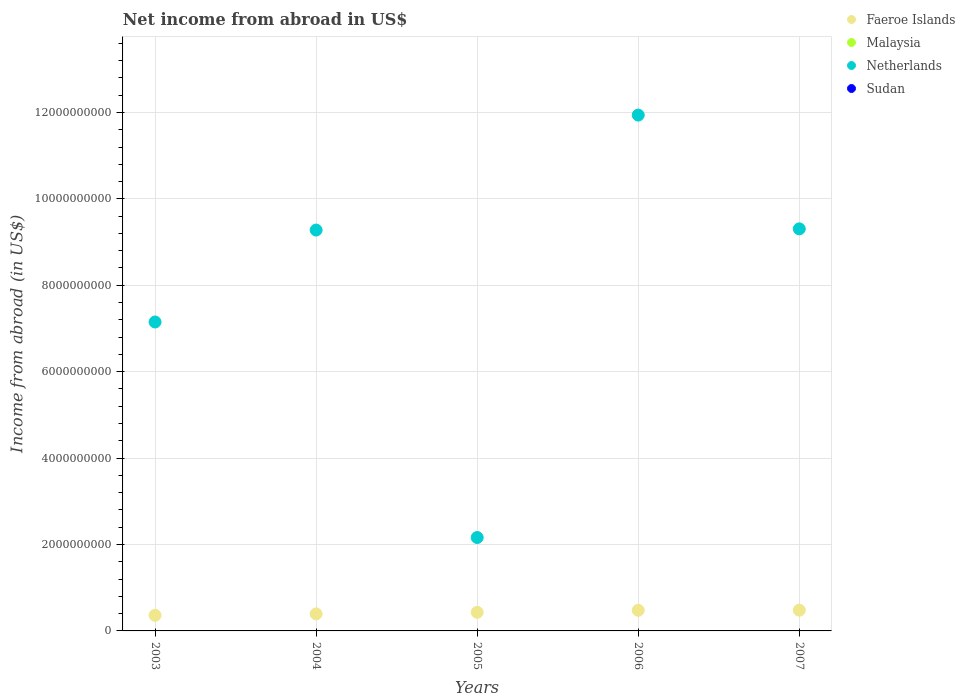How many different coloured dotlines are there?
Make the answer very short. 2. Is the number of dotlines equal to the number of legend labels?
Your answer should be compact. No. What is the net income from abroad in Netherlands in 2003?
Provide a short and direct response. 7.15e+09. Across all years, what is the maximum net income from abroad in Faeroe Islands?
Your answer should be very brief. 4.80e+08. What is the total net income from abroad in Faeroe Islands in the graph?
Offer a very short reply. 2.14e+09. What is the difference between the net income from abroad in Netherlands in 2006 and that in 2007?
Offer a very short reply. 2.63e+09. What is the difference between the net income from abroad in Sudan in 2004 and the net income from abroad in Faeroe Islands in 2007?
Ensure brevity in your answer.  -4.80e+08. What is the average net income from abroad in Faeroe Islands per year?
Keep it short and to the point. 4.29e+08. In the year 2006, what is the difference between the net income from abroad in Faeroe Islands and net income from abroad in Netherlands?
Make the answer very short. -1.15e+1. What is the ratio of the net income from abroad in Faeroe Islands in 2003 to that in 2004?
Keep it short and to the point. 0.92. Is the difference between the net income from abroad in Faeroe Islands in 2003 and 2007 greater than the difference between the net income from abroad in Netherlands in 2003 and 2007?
Give a very brief answer. Yes. What is the difference between the highest and the second highest net income from abroad in Netherlands?
Your response must be concise. 2.63e+09. What is the difference between the highest and the lowest net income from abroad in Netherlands?
Offer a very short reply. 9.78e+09. In how many years, is the net income from abroad in Netherlands greater than the average net income from abroad in Netherlands taken over all years?
Make the answer very short. 3. Does the net income from abroad in Sudan monotonically increase over the years?
Ensure brevity in your answer.  No. Is the net income from abroad in Netherlands strictly greater than the net income from abroad in Malaysia over the years?
Provide a succinct answer. Yes. Is the net income from abroad in Netherlands strictly less than the net income from abroad in Malaysia over the years?
Keep it short and to the point. No. What is the difference between two consecutive major ticks on the Y-axis?
Make the answer very short. 2.00e+09. Are the values on the major ticks of Y-axis written in scientific E-notation?
Offer a very short reply. No. Does the graph contain grids?
Keep it short and to the point. Yes. What is the title of the graph?
Your response must be concise. Net income from abroad in US$. What is the label or title of the X-axis?
Your response must be concise. Years. What is the label or title of the Y-axis?
Give a very brief answer. Income from abroad (in US$). What is the Income from abroad (in US$) of Faeroe Islands in 2003?
Keep it short and to the point. 3.62e+08. What is the Income from abroad (in US$) of Netherlands in 2003?
Keep it short and to the point. 7.15e+09. What is the Income from abroad (in US$) of Faeroe Islands in 2004?
Your response must be concise. 3.94e+08. What is the Income from abroad (in US$) of Netherlands in 2004?
Your answer should be very brief. 9.28e+09. What is the Income from abroad (in US$) in Faeroe Islands in 2005?
Give a very brief answer. 4.31e+08. What is the Income from abroad (in US$) of Malaysia in 2005?
Offer a very short reply. 0. What is the Income from abroad (in US$) of Netherlands in 2005?
Ensure brevity in your answer.  2.16e+09. What is the Income from abroad (in US$) of Faeroe Islands in 2006?
Your answer should be very brief. 4.77e+08. What is the Income from abroad (in US$) of Netherlands in 2006?
Your answer should be very brief. 1.19e+1. What is the Income from abroad (in US$) in Faeroe Islands in 2007?
Your response must be concise. 4.80e+08. What is the Income from abroad (in US$) in Malaysia in 2007?
Your answer should be very brief. 0. What is the Income from abroad (in US$) of Netherlands in 2007?
Make the answer very short. 9.31e+09. Across all years, what is the maximum Income from abroad (in US$) of Faeroe Islands?
Your response must be concise. 4.80e+08. Across all years, what is the maximum Income from abroad (in US$) of Netherlands?
Offer a very short reply. 1.19e+1. Across all years, what is the minimum Income from abroad (in US$) in Faeroe Islands?
Your answer should be very brief. 3.62e+08. Across all years, what is the minimum Income from abroad (in US$) in Netherlands?
Provide a short and direct response. 2.16e+09. What is the total Income from abroad (in US$) of Faeroe Islands in the graph?
Provide a short and direct response. 2.14e+09. What is the total Income from abroad (in US$) of Malaysia in the graph?
Provide a succinct answer. 0. What is the total Income from abroad (in US$) in Netherlands in the graph?
Ensure brevity in your answer.  3.98e+1. What is the difference between the Income from abroad (in US$) of Faeroe Islands in 2003 and that in 2004?
Make the answer very short. -3.25e+07. What is the difference between the Income from abroad (in US$) of Netherlands in 2003 and that in 2004?
Ensure brevity in your answer.  -2.13e+09. What is the difference between the Income from abroad (in US$) in Faeroe Islands in 2003 and that in 2005?
Your answer should be very brief. -6.92e+07. What is the difference between the Income from abroad (in US$) of Netherlands in 2003 and that in 2005?
Make the answer very short. 4.99e+09. What is the difference between the Income from abroad (in US$) of Faeroe Islands in 2003 and that in 2006?
Offer a terse response. -1.15e+08. What is the difference between the Income from abroad (in US$) of Netherlands in 2003 and that in 2006?
Offer a very short reply. -4.79e+09. What is the difference between the Income from abroad (in US$) of Faeroe Islands in 2003 and that in 2007?
Ensure brevity in your answer.  -1.18e+08. What is the difference between the Income from abroad (in US$) in Netherlands in 2003 and that in 2007?
Ensure brevity in your answer.  -2.16e+09. What is the difference between the Income from abroad (in US$) of Faeroe Islands in 2004 and that in 2005?
Make the answer very short. -3.67e+07. What is the difference between the Income from abroad (in US$) in Netherlands in 2004 and that in 2005?
Your answer should be very brief. 7.12e+09. What is the difference between the Income from abroad (in US$) in Faeroe Islands in 2004 and that in 2006?
Your answer should be compact. -8.27e+07. What is the difference between the Income from abroad (in US$) in Netherlands in 2004 and that in 2006?
Provide a short and direct response. -2.66e+09. What is the difference between the Income from abroad (in US$) in Faeroe Islands in 2004 and that in 2007?
Your answer should be very brief. -8.57e+07. What is the difference between the Income from abroad (in US$) of Netherlands in 2004 and that in 2007?
Provide a succinct answer. -2.80e+07. What is the difference between the Income from abroad (in US$) of Faeroe Islands in 2005 and that in 2006?
Make the answer very short. -4.60e+07. What is the difference between the Income from abroad (in US$) of Netherlands in 2005 and that in 2006?
Provide a short and direct response. -9.78e+09. What is the difference between the Income from abroad (in US$) in Faeroe Islands in 2005 and that in 2007?
Ensure brevity in your answer.  -4.90e+07. What is the difference between the Income from abroad (in US$) in Netherlands in 2005 and that in 2007?
Provide a succinct answer. -7.14e+09. What is the difference between the Income from abroad (in US$) in Faeroe Islands in 2006 and that in 2007?
Ensure brevity in your answer.  -3.00e+06. What is the difference between the Income from abroad (in US$) of Netherlands in 2006 and that in 2007?
Offer a very short reply. 2.63e+09. What is the difference between the Income from abroad (in US$) in Faeroe Islands in 2003 and the Income from abroad (in US$) in Netherlands in 2004?
Make the answer very short. -8.92e+09. What is the difference between the Income from abroad (in US$) in Faeroe Islands in 2003 and the Income from abroad (in US$) in Netherlands in 2005?
Ensure brevity in your answer.  -1.80e+09. What is the difference between the Income from abroad (in US$) in Faeroe Islands in 2003 and the Income from abroad (in US$) in Netherlands in 2006?
Ensure brevity in your answer.  -1.16e+1. What is the difference between the Income from abroad (in US$) in Faeroe Islands in 2003 and the Income from abroad (in US$) in Netherlands in 2007?
Offer a terse response. -8.94e+09. What is the difference between the Income from abroad (in US$) of Faeroe Islands in 2004 and the Income from abroad (in US$) of Netherlands in 2005?
Offer a terse response. -1.77e+09. What is the difference between the Income from abroad (in US$) of Faeroe Islands in 2004 and the Income from abroad (in US$) of Netherlands in 2006?
Your response must be concise. -1.15e+1. What is the difference between the Income from abroad (in US$) in Faeroe Islands in 2004 and the Income from abroad (in US$) in Netherlands in 2007?
Provide a succinct answer. -8.91e+09. What is the difference between the Income from abroad (in US$) of Faeroe Islands in 2005 and the Income from abroad (in US$) of Netherlands in 2006?
Your response must be concise. -1.15e+1. What is the difference between the Income from abroad (in US$) in Faeroe Islands in 2005 and the Income from abroad (in US$) in Netherlands in 2007?
Keep it short and to the point. -8.88e+09. What is the difference between the Income from abroad (in US$) of Faeroe Islands in 2006 and the Income from abroad (in US$) of Netherlands in 2007?
Your answer should be compact. -8.83e+09. What is the average Income from abroad (in US$) of Faeroe Islands per year?
Your answer should be very brief. 4.29e+08. What is the average Income from abroad (in US$) in Netherlands per year?
Provide a succinct answer. 7.97e+09. In the year 2003, what is the difference between the Income from abroad (in US$) in Faeroe Islands and Income from abroad (in US$) in Netherlands?
Keep it short and to the point. -6.79e+09. In the year 2004, what is the difference between the Income from abroad (in US$) of Faeroe Islands and Income from abroad (in US$) of Netherlands?
Your response must be concise. -8.88e+09. In the year 2005, what is the difference between the Income from abroad (in US$) of Faeroe Islands and Income from abroad (in US$) of Netherlands?
Provide a succinct answer. -1.73e+09. In the year 2006, what is the difference between the Income from abroad (in US$) of Faeroe Islands and Income from abroad (in US$) of Netherlands?
Offer a very short reply. -1.15e+1. In the year 2007, what is the difference between the Income from abroad (in US$) in Faeroe Islands and Income from abroad (in US$) in Netherlands?
Provide a succinct answer. -8.83e+09. What is the ratio of the Income from abroad (in US$) of Faeroe Islands in 2003 to that in 2004?
Keep it short and to the point. 0.92. What is the ratio of the Income from abroad (in US$) of Netherlands in 2003 to that in 2004?
Offer a terse response. 0.77. What is the ratio of the Income from abroad (in US$) of Faeroe Islands in 2003 to that in 2005?
Offer a very short reply. 0.84. What is the ratio of the Income from abroad (in US$) of Netherlands in 2003 to that in 2005?
Offer a very short reply. 3.31. What is the ratio of the Income from abroad (in US$) in Faeroe Islands in 2003 to that in 2006?
Ensure brevity in your answer.  0.76. What is the ratio of the Income from abroad (in US$) in Netherlands in 2003 to that in 2006?
Keep it short and to the point. 0.6. What is the ratio of the Income from abroad (in US$) in Faeroe Islands in 2003 to that in 2007?
Offer a terse response. 0.75. What is the ratio of the Income from abroad (in US$) in Netherlands in 2003 to that in 2007?
Keep it short and to the point. 0.77. What is the ratio of the Income from abroad (in US$) of Faeroe Islands in 2004 to that in 2005?
Your response must be concise. 0.91. What is the ratio of the Income from abroad (in US$) in Netherlands in 2004 to that in 2005?
Ensure brevity in your answer.  4.29. What is the ratio of the Income from abroad (in US$) of Faeroe Islands in 2004 to that in 2006?
Make the answer very short. 0.83. What is the ratio of the Income from abroad (in US$) in Netherlands in 2004 to that in 2006?
Your answer should be very brief. 0.78. What is the ratio of the Income from abroad (in US$) in Faeroe Islands in 2004 to that in 2007?
Provide a short and direct response. 0.82. What is the ratio of the Income from abroad (in US$) in Netherlands in 2004 to that in 2007?
Provide a short and direct response. 1. What is the ratio of the Income from abroad (in US$) of Faeroe Islands in 2005 to that in 2006?
Your response must be concise. 0.9. What is the ratio of the Income from abroad (in US$) in Netherlands in 2005 to that in 2006?
Make the answer very short. 0.18. What is the ratio of the Income from abroad (in US$) in Faeroe Islands in 2005 to that in 2007?
Provide a short and direct response. 0.9. What is the ratio of the Income from abroad (in US$) of Netherlands in 2005 to that in 2007?
Your answer should be very brief. 0.23. What is the ratio of the Income from abroad (in US$) of Faeroe Islands in 2006 to that in 2007?
Provide a succinct answer. 0.99. What is the ratio of the Income from abroad (in US$) in Netherlands in 2006 to that in 2007?
Your response must be concise. 1.28. What is the difference between the highest and the second highest Income from abroad (in US$) of Faeroe Islands?
Your response must be concise. 3.00e+06. What is the difference between the highest and the second highest Income from abroad (in US$) of Netherlands?
Your answer should be compact. 2.63e+09. What is the difference between the highest and the lowest Income from abroad (in US$) of Faeroe Islands?
Offer a very short reply. 1.18e+08. What is the difference between the highest and the lowest Income from abroad (in US$) in Netherlands?
Offer a very short reply. 9.78e+09. 